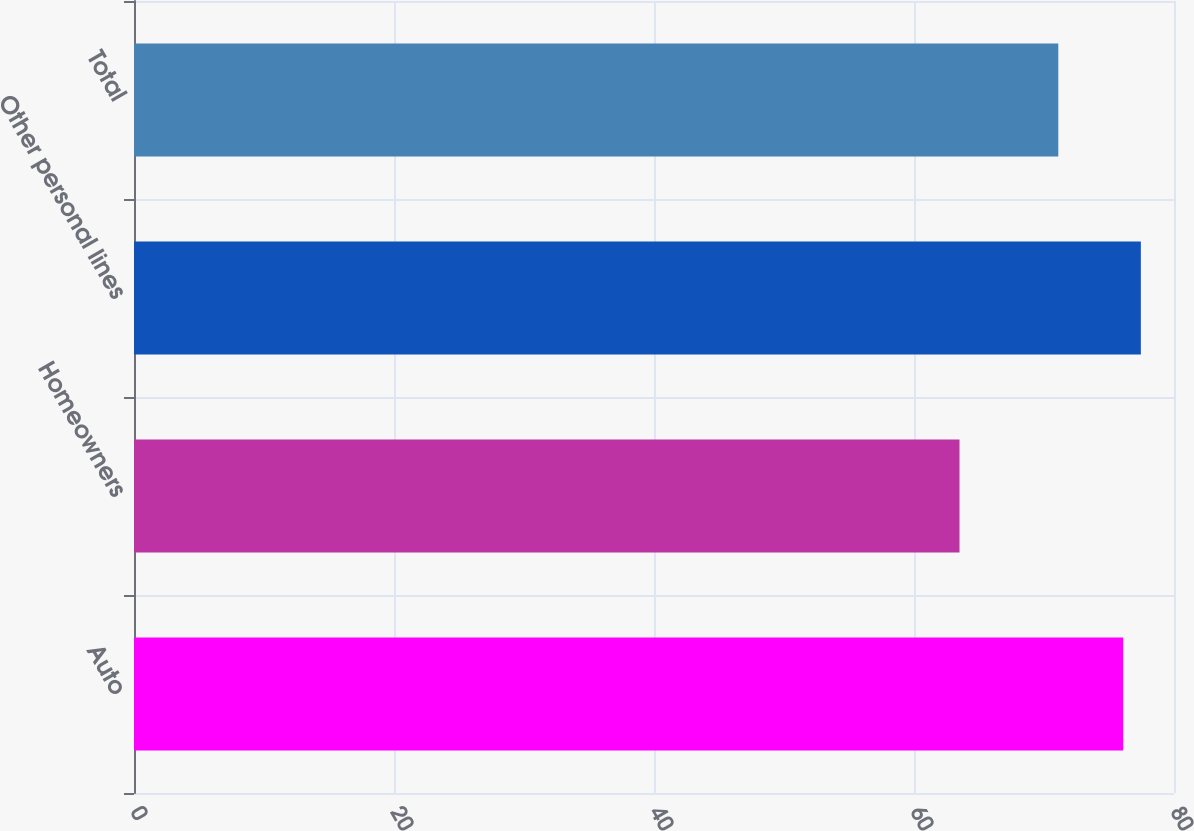Convert chart to OTSL. <chart><loc_0><loc_0><loc_500><loc_500><bar_chart><fcel>Auto<fcel>Homeowners<fcel>Other personal lines<fcel>Total<nl><fcel>76.1<fcel>63.5<fcel>77.45<fcel>71.1<nl></chart> 